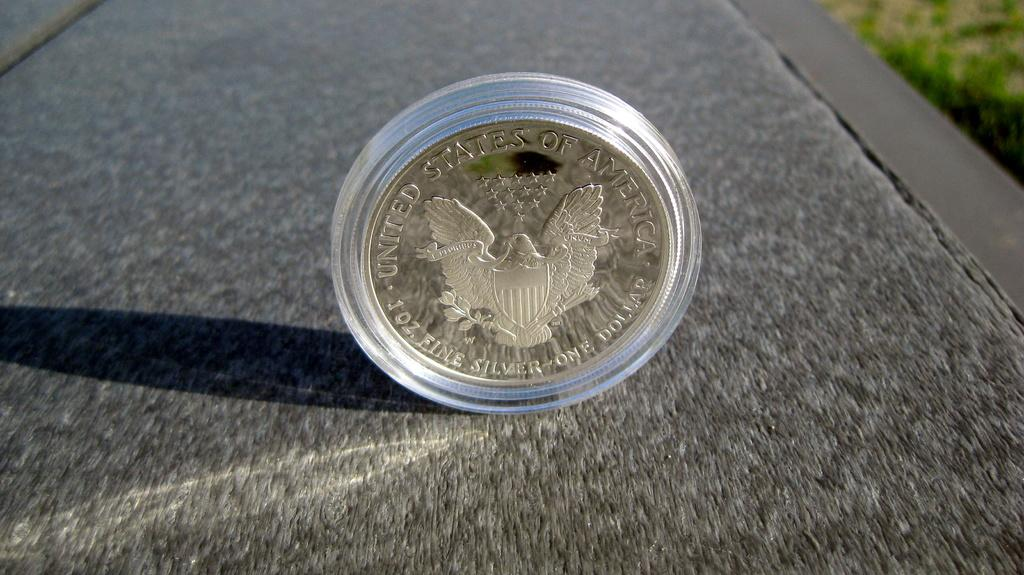<image>
Relay a brief, clear account of the picture shown. a silver dollar coin in a case, the united states of america text above the eagle and shield 